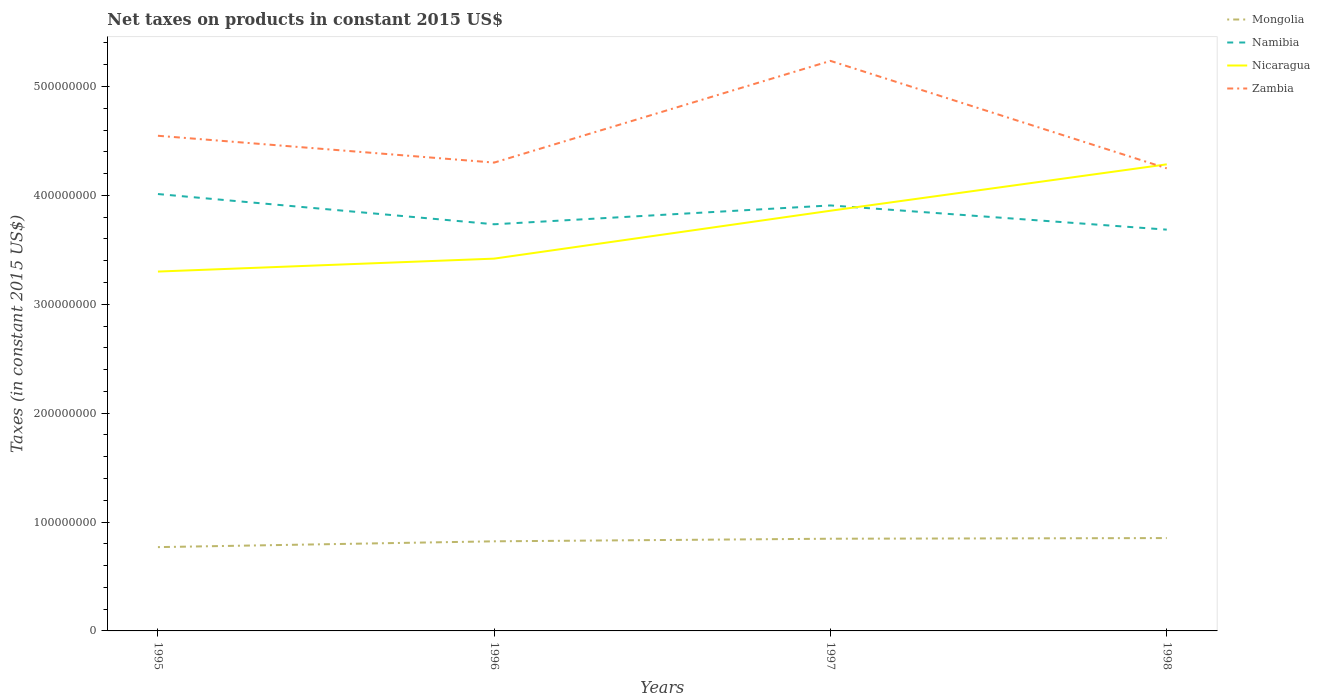How many different coloured lines are there?
Offer a very short reply. 4. Is the number of lines equal to the number of legend labels?
Make the answer very short. Yes. Across all years, what is the maximum net taxes on products in Zambia?
Provide a succinct answer. 4.25e+08. In which year was the net taxes on products in Mongolia maximum?
Ensure brevity in your answer.  1995. What is the total net taxes on products in Mongolia in the graph?
Your response must be concise. -6.02e+05. What is the difference between the highest and the second highest net taxes on products in Namibia?
Provide a short and direct response. 3.27e+07. What is the difference between the highest and the lowest net taxes on products in Nicaragua?
Your answer should be compact. 2. Is the net taxes on products in Zambia strictly greater than the net taxes on products in Nicaragua over the years?
Ensure brevity in your answer.  No. How many years are there in the graph?
Keep it short and to the point. 4. What is the difference between two consecutive major ticks on the Y-axis?
Give a very brief answer. 1.00e+08. Are the values on the major ticks of Y-axis written in scientific E-notation?
Your response must be concise. No. How are the legend labels stacked?
Provide a succinct answer. Vertical. What is the title of the graph?
Your answer should be compact. Net taxes on products in constant 2015 US$. What is the label or title of the X-axis?
Your answer should be compact. Years. What is the label or title of the Y-axis?
Ensure brevity in your answer.  Taxes (in constant 2015 US$). What is the Taxes (in constant 2015 US$) of Mongolia in 1995?
Provide a short and direct response. 7.70e+07. What is the Taxes (in constant 2015 US$) of Namibia in 1995?
Ensure brevity in your answer.  4.01e+08. What is the Taxes (in constant 2015 US$) of Nicaragua in 1995?
Provide a succinct answer. 3.30e+08. What is the Taxes (in constant 2015 US$) in Zambia in 1995?
Provide a short and direct response. 4.55e+08. What is the Taxes (in constant 2015 US$) of Mongolia in 1996?
Make the answer very short. 8.23e+07. What is the Taxes (in constant 2015 US$) of Namibia in 1996?
Make the answer very short. 3.73e+08. What is the Taxes (in constant 2015 US$) of Nicaragua in 1996?
Your answer should be compact. 3.42e+08. What is the Taxes (in constant 2015 US$) in Zambia in 1996?
Provide a succinct answer. 4.30e+08. What is the Taxes (in constant 2015 US$) of Mongolia in 1997?
Provide a succinct answer. 8.47e+07. What is the Taxes (in constant 2015 US$) in Namibia in 1997?
Provide a succinct answer. 3.91e+08. What is the Taxes (in constant 2015 US$) in Nicaragua in 1997?
Your answer should be very brief. 3.86e+08. What is the Taxes (in constant 2015 US$) in Zambia in 1997?
Offer a terse response. 5.23e+08. What is the Taxes (in constant 2015 US$) of Mongolia in 1998?
Your response must be concise. 8.53e+07. What is the Taxes (in constant 2015 US$) in Namibia in 1998?
Ensure brevity in your answer.  3.69e+08. What is the Taxes (in constant 2015 US$) of Nicaragua in 1998?
Offer a very short reply. 4.28e+08. What is the Taxes (in constant 2015 US$) in Zambia in 1998?
Your answer should be compact. 4.25e+08. Across all years, what is the maximum Taxes (in constant 2015 US$) in Mongolia?
Provide a succinct answer. 8.53e+07. Across all years, what is the maximum Taxes (in constant 2015 US$) in Namibia?
Provide a succinct answer. 4.01e+08. Across all years, what is the maximum Taxes (in constant 2015 US$) in Nicaragua?
Your answer should be very brief. 4.28e+08. Across all years, what is the maximum Taxes (in constant 2015 US$) in Zambia?
Ensure brevity in your answer.  5.23e+08. Across all years, what is the minimum Taxes (in constant 2015 US$) in Mongolia?
Offer a terse response. 7.70e+07. Across all years, what is the minimum Taxes (in constant 2015 US$) of Namibia?
Ensure brevity in your answer.  3.69e+08. Across all years, what is the minimum Taxes (in constant 2015 US$) in Nicaragua?
Provide a short and direct response. 3.30e+08. Across all years, what is the minimum Taxes (in constant 2015 US$) in Zambia?
Provide a short and direct response. 4.25e+08. What is the total Taxes (in constant 2015 US$) in Mongolia in the graph?
Offer a terse response. 3.29e+08. What is the total Taxes (in constant 2015 US$) of Namibia in the graph?
Your answer should be very brief. 1.53e+09. What is the total Taxes (in constant 2015 US$) in Nicaragua in the graph?
Provide a succinct answer. 1.49e+09. What is the total Taxes (in constant 2015 US$) of Zambia in the graph?
Provide a short and direct response. 1.83e+09. What is the difference between the Taxes (in constant 2015 US$) in Mongolia in 1995 and that in 1996?
Your answer should be compact. -5.34e+06. What is the difference between the Taxes (in constant 2015 US$) in Namibia in 1995 and that in 1996?
Give a very brief answer. 2.78e+07. What is the difference between the Taxes (in constant 2015 US$) in Nicaragua in 1995 and that in 1996?
Your answer should be very brief. -1.19e+07. What is the difference between the Taxes (in constant 2015 US$) in Zambia in 1995 and that in 1996?
Provide a short and direct response. 2.46e+07. What is the difference between the Taxes (in constant 2015 US$) of Mongolia in 1995 and that in 1997?
Ensure brevity in your answer.  -7.72e+06. What is the difference between the Taxes (in constant 2015 US$) of Namibia in 1995 and that in 1997?
Your response must be concise. 1.05e+07. What is the difference between the Taxes (in constant 2015 US$) of Nicaragua in 1995 and that in 1997?
Your response must be concise. -5.59e+07. What is the difference between the Taxes (in constant 2015 US$) of Zambia in 1995 and that in 1997?
Offer a very short reply. -6.88e+07. What is the difference between the Taxes (in constant 2015 US$) of Mongolia in 1995 and that in 1998?
Ensure brevity in your answer.  -8.32e+06. What is the difference between the Taxes (in constant 2015 US$) in Namibia in 1995 and that in 1998?
Make the answer very short. 3.27e+07. What is the difference between the Taxes (in constant 2015 US$) in Nicaragua in 1995 and that in 1998?
Provide a short and direct response. -9.85e+07. What is the difference between the Taxes (in constant 2015 US$) of Zambia in 1995 and that in 1998?
Provide a succinct answer. 2.99e+07. What is the difference between the Taxes (in constant 2015 US$) in Mongolia in 1996 and that in 1997?
Offer a terse response. -2.38e+06. What is the difference between the Taxes (in constant 2015 US$) of Namibia in 1996 and that in 1997?
Your answer should be compact. -1.73e+07. What is the difference between the Taxes (in constant 2015 US$) of Nicaragua in 1996 and that in 1997?
Offer a terse response. -4.40e+07. What is the difference between the Taxes (in constant 2015 US$) in Zambia in 1996 and that in 1997?
Keep it short and to the point. -9.34e+07. What is the difference between the Taxes (in constant 2015 US$) of Mongolia in 1996 and that in 1998?
Ensure brevity in your answer.  -2.98e+06. What is the difference between the Taxes (in constant 2015 US$) in Namibia in 1996 and that in 1998?
Ensure brevity in your answer.  4.93e+06. What is the difference between the Taxes (in constant 2015 US$) in Nicaragua in 1996 and that in 1998?
Offer a terse response. -8.66e+07. What is the difference between the Taxes (in constant 2015 US$) of Zambia in 1996 and that in 1998?
Provide a short and direct response. 5.27e+06. What is the difference between the Taxes (in constant 2015 US$) in Mongolia in 1997 and that in 1998?
Your answer should be compact. -6.02e+05. What is the difference between the Taxes (in constant 2015 US$) of Namibia in 1997 and that in 1998?
Offer a very short reply. 2.22e+07. What is the difference between the Taxes (in constant 2015 US$) of Nicaragua in 1997 and that in 1998?
Give a very brief answer. -4.26e+07. What is the difference between the Taxes (in constant 2015 US$) of Zambia in 1997 and that in 1998?
Your answer should be compact. 9.87e+07. What is the difference between the Taxes (in constant 2015 US$) in Mongolia in 1995 and the Taxes (in constant 2015 US$) in Namibia in 1996?
Your answer should be compact. -2.96e+08. What is the difference between the Taxes (in constant 2015 US$) in Mongolia in 1995 and the Taxes (in constant 2015 US$) in Nicaragua in 1996?
Give a very brief answer. -2.65e+08. What is the difference between the Taxes (in constant 2015 US$) of Mongolia in 1995 and the Taxes (in constant 2015 US$) of Zambia in 1996?
Your response must be concise. -3.53e+08. What is the difference between the Taxes (in constant 2015 US$) of Namibia in 1995 and the Taxes (in constant 2015 US$) of Nicaragua in 1996?
Ensure brevity in your answer.  5.93e+07. What is the difference between the Taxes (in constant 2015 US$) of Namibia in 1995 and the Taxes (in constant 2015 US$) of Zambia in 1996?
Your answer should be compact. -2.89e+07. What is the difference between the Taxes (in constant 2015 US$) of Nicaragua in 1995 and the Taxes (in constant 2015 US$) of Zambia in 1996?
Provide a short and direct response. -1.00e+08. What is the difference between the Taxes (in constant 2015 US$) of Mongolia in 1995 and the Taxes (in constant 2015 US$) of Namibia in 1997?
Your answer should be compact. -3.14e+08. What is the difference between the Taxes (in constant 2015 US$) of Mongolia in 1995 and the Taxes (in constant 2015 US$) of Nicaragua in 1997?
Your answer should be very brief. -3.09e+08. What is the difference between the Taxes (in constant 2015 US$) of Mongolia in 1995 and the Taxes (in constant 2015 US$) of Zambia in 1997?
Ensure brevity in your answer.  -4.47e+08. What is the difference between the Taxes (in constant 2015 US$) of Namibia in 1995 and the Taxes (in constant 2015 US$) of Nicaragua in 1997?
Keep it short and to the point. 1.53e+07. What is the difference between the Taxes (in constant 2015 US$) in Namibia in 1995 and the Taxes (in constant 2015 US$) in Zambia in 1997?
Your response must be concise. -1.22e+08. What is the difference between the Taxes (in constant 2015 US$) of Nicaragua in 1995 and the Taxes (in constant 2015 US$) of Zambia in 1997?
Offer a terse response. -1.93e+08. What is the difference between the Taxes (in constant 2015 US$) of Mongolia in 1995 and the Taxes (in constant 2015 US$) of Namibia in 1998?
Your answer should be very brief. -2.92e+08. What is the difference between the Taxes (in constant 2015 US$) in Mongolia in 1995 and the Taxes (in constant 2015 US$) in Nicaragua in 1998?
Keep it short and to the point. -3.52e+08. What is the difference between the Taxes (in constant 2015 US$) of Mongolia in 1995 and the Taxes (in constant 2015 US$) of Zambia in 1998?
Give a very brief answer. -3.48e+08. What is the difference between the Taxes (in constant 2015 US$) in Namibia in 1995 and the Taxes (in constant 2015 US$) in Nicaragua in 1998?
Your answer should be compact. -2.73e+07. What is the difference between the Taxes (in constant 2015 US$) of Namibia in 1995 and the Taxes (in constant 2015 US$) of Zambia in 1998?
Make the answer very short. -2.36e+07. What is the difference between the Taxes (in constant 2015 US$) of Nicaragua in 1995 and the Taxes (in constant 2015 US$) of Zambia in 1998?
Your answer should be very brief. -9.48e+07. What is the difference between the Taxes (in constant 2015 US$) in Mongolia in 1996 and the Taxes (in constant 2015 US$) in Namibia in 1997?
Provide a short and direct response. -3.08e+08. What is the difference between the Taxes (in constant 2015 US$) of Mongolia in 1996 and the Taxes (in constant 2015 US$) of Nicaragua in 1997?
Offer a very short reply. -3.04e+08. What is the difference between the Taxes (in constant 2015 US$) in Mongolia in 1996 and the Taxes (in constant 2015 US$) in Zambia in 1997?
Ensure brevity in your answer.  -4.41e+08. What is the difference between the Taxes (in constant 2015 US$) of Namibia in 1996 and the Taxes (in constant 2015 US$) of Nicaragua in 1997?
Your response must be concise. -1.24e+07. What is the difference between the Taxes (in constant 2015 US$) of Namibia in 1996 and the Taxes (in constant 2015 US$) of Zambia in 1997?
Provide a short and direct response. -1.50e+08. What is the difference between the Taxes (in constant 2015 US$) of Nicaragua in 1996 and the Taxes (in constant 2015 US$) of Zambia in 1997?
Give a very brief answer. -1.82e+08. What is the difference between the Taxes (in constant 2015 US$) of Mongolia in 1996 and the Taxes (in constant 2015 US$) of Namibia in 1998?
Offer a very short reply. -2.86e+08. What is the difference between the Taxes (in constant 2015 US$) in Mongolia in 1996 and the Taxes (in constant 2015 US$) in Nicaragua in 1998?
Your answer should be compact. -3.46e+08. What is the difference between the Taxes (in constant 2015 US$) in Mongolia in 1996 and the Taxes (in constant 2015 US$) in Zambia in 1998?
Provide a short and direct response. -3.43e+08. What is the difference between the Taxes (in constant 2015 US$) in Namibia in 1996 and the Taxes (in constant 2015 US$) in Nicaragua in 1998?
Your answer should be very brief. -5.50e+07. What is the difference between the Taxes (in constant 2015 US$) in Namibia in 1996 and the Taxes (in constant 2015 US$) in Zambia in 1998?
Provide a short and direct response. -5.14e+07. What is the difference between the Taxes (in constant 2015 US$) in Nicaragua in 1996 and the Taxes (in constant 2015 US$) in Zambia in 1998?
Ensure brevity in your answer.  -8.29e+07. What is the difference between the Taxes (in constant 2015 US$) of Mongolia in 1997 and the Taxes (in constant 2015 US$) of Namibia in 1998?
Give a very brief answer. -2.84e+08. What is the difference between the Taxes (in constant 2015 US$) in Mongolia in 1997 and the Taxes (in constant 2015 US$) in Nicaragua in 1998?
Keep it short and to the point. -3.44e+08. What is the difference between the Taxes (in constant 2015 US$) of Mongolia in 1997 and the Taxes (in constant 2015 US$) of Zambia in 1998?
Keep it short and to the point. -3.40e+08. What is the difference between the Taxes (in constant 2015 US$) in Namibia in 1997 and the Taxes (in constant 2015 US$) in Nicaragua in 1998?
Offer a very short reply. -3.77e+07. What is the difference between the Taxes (in constant 2015 US$) in Namibia in 1997 and the Taxes (in constant 2015 US$) in Zambia in 1998?
Offer a very short reply. -3.41e+07. What is the difference between the Taxes (in constant 2015 US$) of Nicaragua in 1997 and the Taxes (in constant 2015 US$) of Zambia in 1998?
Your answer should be compact. -3.89e+07. What is the average Taxes (in constant 2015 US$) in Mongolia per year?
Offer a terse response. 8.23e+07. What is the average Taxes (in constant 2015 US$) in Namibia per year?
Offer a terse response. 3.83e+08. What is the average Taxes (in constant 2015 US$) in Nicaragua per year?
Your response must be concise. 3.72e+08. What is the average Taxes (in constant 2015 US$) in Zambia per year?
Offer a very short reply. 4.58e+08. In the year 1995, what is the difference between the Taxes (in constant 2015 US$) in Mongolia and Taxes (in constant 2015 US$) in Namibia?
Give a very brief answer. -3.24e+08. In the year 1995, what is the difference between the Taxes (in constant 2015 US$) of Mongolia and Taxes (in constant 2015 US$) of Nicaragua?
Your response must be concise. -2.53e+08. In the year 1995, what is the difference between the Taxes (in constant 2015 US$) in Mongolia and Taxes (in constant 2015 US$) in Zambia?
Provide a short and direct response. -3.78e+08. In the year 1995, what is the difference between the Taxes (in constant 2015 US$) in Namibia and Taxes (in constant 2015 US$) in Nicaragua?
Your answer should be very brief. 7.12e+07. In the year 1995, what is the difference between the Taxes (in constant 2015 US$) in Namibia and Taxes (in constant 2015 US$) in Zambia?
Keep it short and to the point. -5.35e+07. In the year 1995, what is the difference between the Taxes (in constant 2015 US$) in Nicaragua and Taxes (in constant 2015 US$) in Zambia?
Your answer should be very brief. -1.25e+08. In the year 1996, what is the difference between the Taxes (in constant 2015 US$) in Mongolia and Taxes (in constant 2015 US$) in Namibia?
Give a very brief answer. -2.91e+08. In the year 1996, what is the difference between the Taxes (in constant 2015 US$) of Mongolia and Taxes (in constant 2015 US$) of Nicaragua?
Give a very brief answer. -2.60e+08. In the year 1996, what is the difference between the Taxes (in constant 2015 US$) in Mongolia and Taxes (in constant 2015 US$) in Zambia?
Ensure brevity in your answer.  -3.48e+08. In the year 1996, what is the difference between the Taxes (in constant 2015 US$) of Namibia and Taxes (in constant 2015 US$) of Nicaragua?
Provide a short and direct response. 3.15e+07. In the year 1996, what is the difference between the Taxes (in constant 2015 US$) of Namibia and Taxes (in constant 2015 US$) of Zambia?
Your answer should be compact. -5.66e+07. In the year 1996, what is the difference between the Taxes (in constant 2015 US$) of Nicaragua and Taxes (in constant 2015 US$) of Zambia?
Keep it short and to the point. -8.82e+07. In the year 1997, what is the difference between the Taxes (in constant 2015 US$) in Mongolia and Taxes (in constant 2015 US$) in Namibia?
Provide a short and direct response. -3.06e+08. In the year 1997, what is the difference between the Taxes (in constant 2015 US$) of Mongolia and Taxes (in constant 2015 US$) of Nicaragua?
Ensure brevity in your answer.  -3.01e+08. In the year 1997, what is the difference between the Taxes (in constant 2015 US$) in Mongolia and Taxes (in constant 2015 US$) in Zambia?
Provide a succinct answer. -4.39e+08. In the year 1997, what is the difference between the Taxes (in constant 2015 US$) of Namibia and Taxes (in constant 2015 US$) of Nicaragua?
Your response must be concise. 4.87e+06. In the year 1997, what is the difference between the Taxes (in constant 2015 US$) in Namibia and Taxes (in constant 2015 US$) in Zambia?
Your response must be concise. -1.33e+08. In the year 1997, what is the difference between the Taxes (in constant 2015 US$) of Nicaragua and Taxes (in constant 2015 US$) of Zambia?
Ensure brevity in your answer.  -1.38e+08. In the year 1998, what is the difference between the Taxes (in constant 2015 US$) of Mongolia and Taxes (in constant 2015 US$) of Namibia?
Your answer should be compact. -2.83e+08. In the year 1998, what is the difference between the Taxes (in constant 2015 US$) of Mongolia and Taxes (in constant 2015 US$) of Nicaragua?
Your answer should be very brief. -3.43e+08. In the year 1998, what is the difference between the Taxes (in constant 2015 US$) in Mongolia and Taxes (in constant 2015 US$) in Zambia?
Your answer should be very brief. -3.40e+08. In the year 1998, what is the difference between the Taxes (in constant 2015 US$) of Namibia and Taxes (in constant 2015 US$) of Nicaragua?
Make the answer very short. -6.00e+07. In the year 1998, what is the difference between the Taxes (in constant 2015 US$) in Namibia and Taxes (in constant 2015 US$) in Zambia?
Make the answer very short. -5.63e+07. In the year 1998, what is the difference between the Taxes (in constant 2015 US$) of Nicaragua and Taxes (in constant 2015 US$) of Zambia?
Ensure brevity in your answer.  3.67e+06. What is the ratio of the Taxes (in constant 2015 US$) of Mongolia in 1995 to that in 1996?
Your response must be concise. 0.94. What is the ratio of the Taxes (in constant 2015 US$) of Namibia in 1995 to that in 1996?
Your answer should be compact. 1.07. What is the ratio of the Taxes (in constant 2015 US$) of Nicaragua in 1995 to that in 1996?
Provide a succinct answer. 0.97. What is the ratio of the Taxes (in constant 2015 US$) of Zambia in 1995 to that in 1996?
Offer a terse response. 1.06. What is the ratio of the Taxes (in constant 2015 US$) of Mongolia in 1995 to that in 1997?
Your answer should be very brief. 0.91. What is the ratio of the Taxes (in constant 2015 US$) in Namibia in 1995 to that in 1997?
Provide a succinct answer. 1.03. What is the ratio of the Taxes (in constant 2015 US$) in Nicaragua in 1995 to that in 1997?
Provide a succinct answer. 0.86. What is the ratio of the Taxes (in constant 2015 US$) in Zambia in 1995 to that in 1997?
Your response must be concise. 0.87. What is the ratio of the Taxes (in constant 2015 US$) in Mongolia in 1995 to that in 1998?
Make the answer very short. 0.9. What is the ratio of the Taxes (in constant 2015 US$) of Namibia in 1995 to that in 1998?
Your response must be concise. 1.09. What is the ratio of the Taxes (in constant 2015 US$) in Nicaragua in 1995 to that in 1998?
Make the answer very short. 0.77. What is the ratio of the Taxes (in constant 2015 US$) of Zambia in 1995 to that in 1998?
Offer a terse response. 1.07. What is the ratio of the Taxes (in constant 2015 US$) in Mongolia in 1996 to that in 1997?
Offer a terse response. 0.97. What is the ratio of the Taxes (in constant 2015 US$) of Namibia in 1996 to that in 1997?
Provide a succinct answer. 0.96. What is the ratio of the Taxes (in constant 2015 US$) of Nicaragua in 1996 to that in 1997?
Provide a short and direct response. 0.89. What is the ratio of the Taxes (in constant 2015 US$) in Zambia in 1996 to that in 1997?
Your response must be concise. 0.82. What is the ratio of the Taxes (in constant 2015 US$) of Namibia in 1996 to that in 1998?
Provide a short and direct response. 1.01. What is the ratio of the Taxes (in constant 2015 US$) in Nicaragua in 1996 to that in 1998?
Offer a very short reply. 0.8. What is the ratio of the Taxes (in constant 2015 US$) of Zambia in 1996 to that in 1998?
Keep it short and to the point. 1.01. What is the ratio of the Taxes (in constant 2015 US$) in Namibia in 1997 to that in 1998?
Offer a very short reply. 1.06. What is the ratio of the Taxes (in constant 2015 US$) of Nicaragua in 1997 to that in 1998?
Make the answer very short. 0.9. What is the ratio of the Taxes (in constant 2015 US$) in Zambia in 1997 to that in 1998?
Offer a terse response. 1.23. What is the difference between the highest and the second highest Taxes (in constant 2015 US$) of Mongolia?
Offer a terse response. 6.02e+05. What is the difference between the highest and the second highest Taxes (in constant 2015 US$) of Namibia?
Offer a very short reply. 1.05e+07. What is the difference between the highest and the second highest Taxes (in constant 2015 US$) of Nicaragua?
Offer a very short reply. 4.26e+07. What is the difference between the highest and the second highest Taxes (in constant 2015 US$) in Zambia?
Offer a very short reply. 6.88e+07. What is the difference between the highest and the lowest Taxes (in constant 2015 US$) of Mongolia?
Your answer should be very brief. 8.32e+06. What is the difference between the highest and the lowest Taxes (in constant 2015 US$) of Namibia?
Offer a terse response. 3.27e+07. What is the difference between the highest and the lowest Taxes (in constant 2015 US$) in Nicaragua?
Provide a succinct answer. 9.85e+07. What is the difference between the highest and the lowest Taxes (in constant 2015 US$) in Zambia?
Provide a short and direct response. 9.87e+07. 